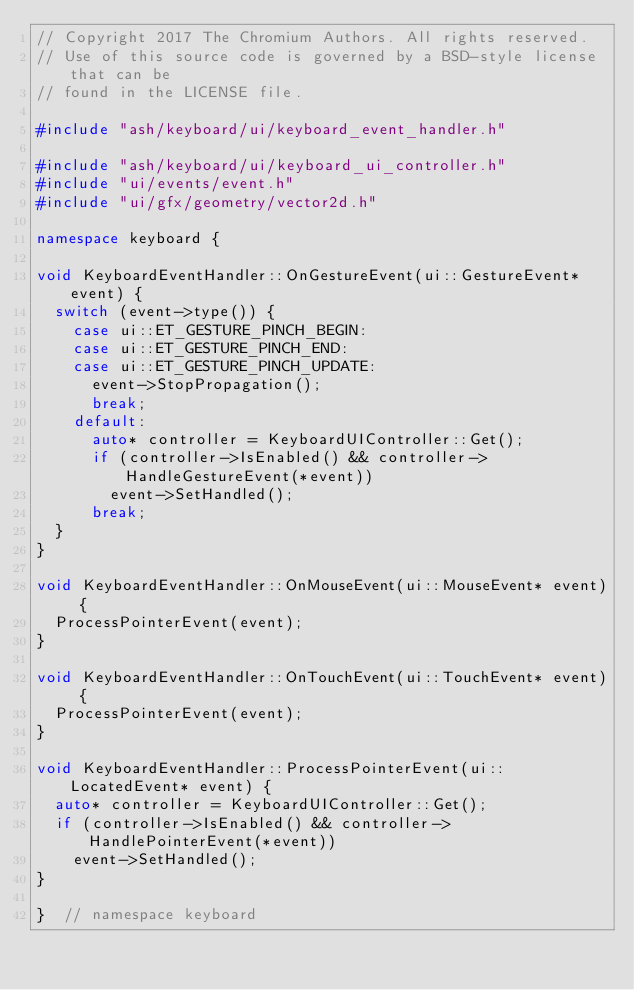<code> <loc_0><loc_0><loc_500><loc_500><_C++_>// Copyright 2017 The Chromium Authors. All rights reserved.
// Use of this source code is governed by a BSD-style license that can be
// found in the LICENSE file.

#include "ash/keyboard/ui/keyboard_event_handler.h"

#include "ash/keyboard/ui/keyboard_ui_controller.h"
#include "ui/events/event.h"
#include "ui/gfx/geometry/vector2d.h"

namespace keyboard {

void KeyboardEventHandler::OnGestureEvent(ui::GestureEvent* event) {
  switch (event->type()) {
    case ui::ET_GESTURE_PINCH_BEGIN:
    case ui::ET_GESTURE_PINCH_END:
    case ui::ET_GESTURE_PINCH_UPDATE:
      event->StopPropagation();
      break;
    default:
      auto* controller = KeyboardUIController::Get();
      if (controller->IsEnabled() && controller->HandleGestureEvent(*event))
        event->SetHandled();
      break;
  }
}

void KeyboardEventHandler::OnMouseEvent(ui::MouseEvent* event) {
  ProcessPointerEvent(event);
}

void KeyboardEventHandler::OnTouchEvent(ui::TouchEvent* event) {
  ProcessPointerEvent(event);
}

void KeyboardEventHandler::ProcessPointerEvent(ui::LocatedEvent* event) {
  auto* controller = KeyboardUIController::Get();
  if (controller->IsEnabled() && controller->HandlePointerEvent(*event))
    event->SetHandled();
}

}  // namespace keyboard
</code> 